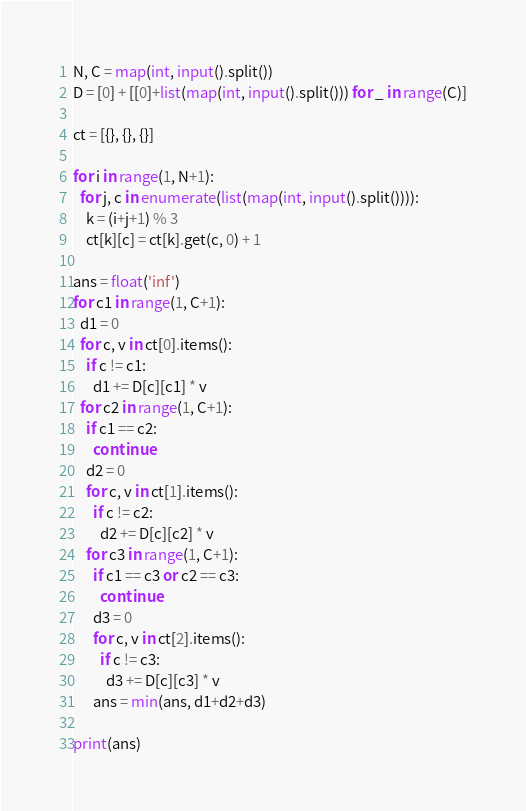Convert code to text. <code><loc_0><loc_0><loc_500><loc_500><_Python_>N, C = map(int, input().split())
D = [0] + [[0]+list(map(int, input().split())) for _ in range(C)]

ct = [{}, {}, {}]

for i in range(1, N+1):
  for j, c in enumerate(list(map(int, input().split()))):
    k = (i+j+1) % 3
    ct[k][c] = ct[k].get(c, 0) + 1

ans = float('inf')
for c1 in range(1, C+1):
  d1 = 0
  for c, v in ct[0].items():
    if c != c1:
      d1 += D[c][c1] * v
  for c2 in range(1, C+1):
    if c1 == c2:
      continue
    d2 = 0
    for c, v in ct[1].items():
      if c != c2:
        d2 += D[c][c2] * v
    for c3 in range(1, C+1):
      if c1 == c3 or c2 == c3:
        continue
      d3 = 0
      for c, v in ct[2].items():
        if c != c3:
          d3 += D[c][c3] * v
      ans = min(ans, d1+d2+d3)

print(ans)</code> 